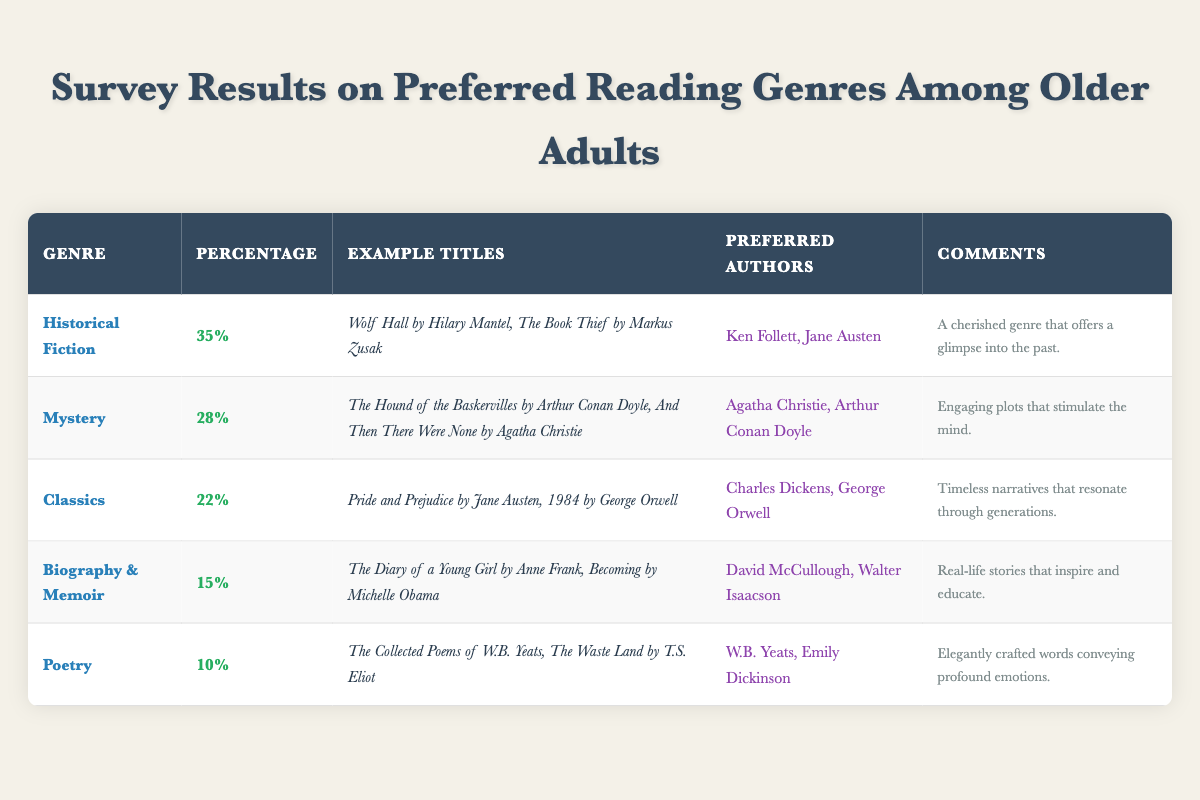What is the most preferred reading genre among older adults? The table indicates that Historical Fiction has the highest percentage of preference at 35% among older adults.
Answer: Historical Fiction What percentage of older adults prefer the Mystery genre? According to the table, the percentage of older adults who prefer the Mystery genre is 28%.
Answer: 28% Which genre has the lowest percentage of preference? The table shows that Poetry has the lowest preference at 10%.
Answer: Poetry What are two example titles for the Classics genre? The table lists "Pride and Prejudice by Jane Austen" and "1984 by George Orwell" as example titles for the Classics genre.
Answer: Pride and Prejudice by Jane Austen, 1984 by George Orwell Which authors are preferred for Biography & Memoir? The survey results list David McCullough and Walter Isaacson as preferred authors for the Biography & Memoir genre.
Answer: David McCullough, Walter Isaacson What is the combined percentage of older adults who prefer Biography & Memoir and Poetry? The percentage for Biography & Memoir is 15% and for Poetry is 10%, adding these together gives 15% + 10% = 25%.
Answer: 25% Is Agatha Christie among the preferred authors for the Mystery genre according to the data? Yes, the table confirms that Agatha Christie is listed as one of the preferred authors for the Mystery genre.
Answer: Yes Which genre has a higher preference percentage, Classics or Biography & Memoir? The percentage for Classics is 22% and for Biography & Memoir is 15%, thus Classics has a higher preference.
Answer: Classics What is the common theme reflected in the comments for Historical Fiction and Biography & Memoir? Both comments highlight the value of storytelling, with Historical Fiction offering a glimpse into the past, while Biography & Memoir provides real-life inspiration and education.
Answer: Storytelling and inspiration What is the total percentage of older adults who prefer Historical Fiction and Mystery combined? Historical Fiction is 35% and Mystery is 28%, hence they total to 35% + 28% = 63%.
Answer: 63% 